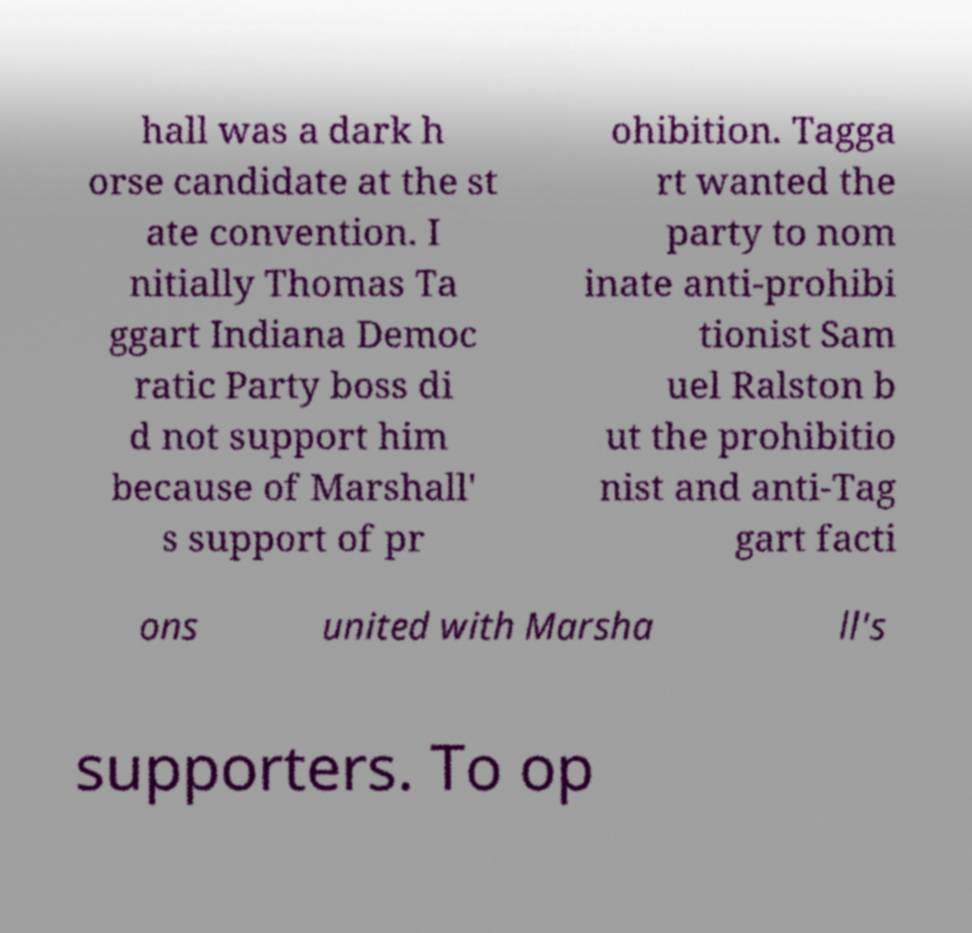What messages or text are displayed in this image? I need them in a readable, typed format. hall was a dark h orse candidate at the st ate convention. I nitially Thomas Ta ggart Indiana Democ ratic Party boss di d not support him because of Marshall' s support of pr ohibition. Tagga rt wanted the party to nom inate anti-prohibi tionist Sam uel Ralston b ut the prohibitio nist and anti-Tag gart facti ons united with Marsha ll's supporters. To op 